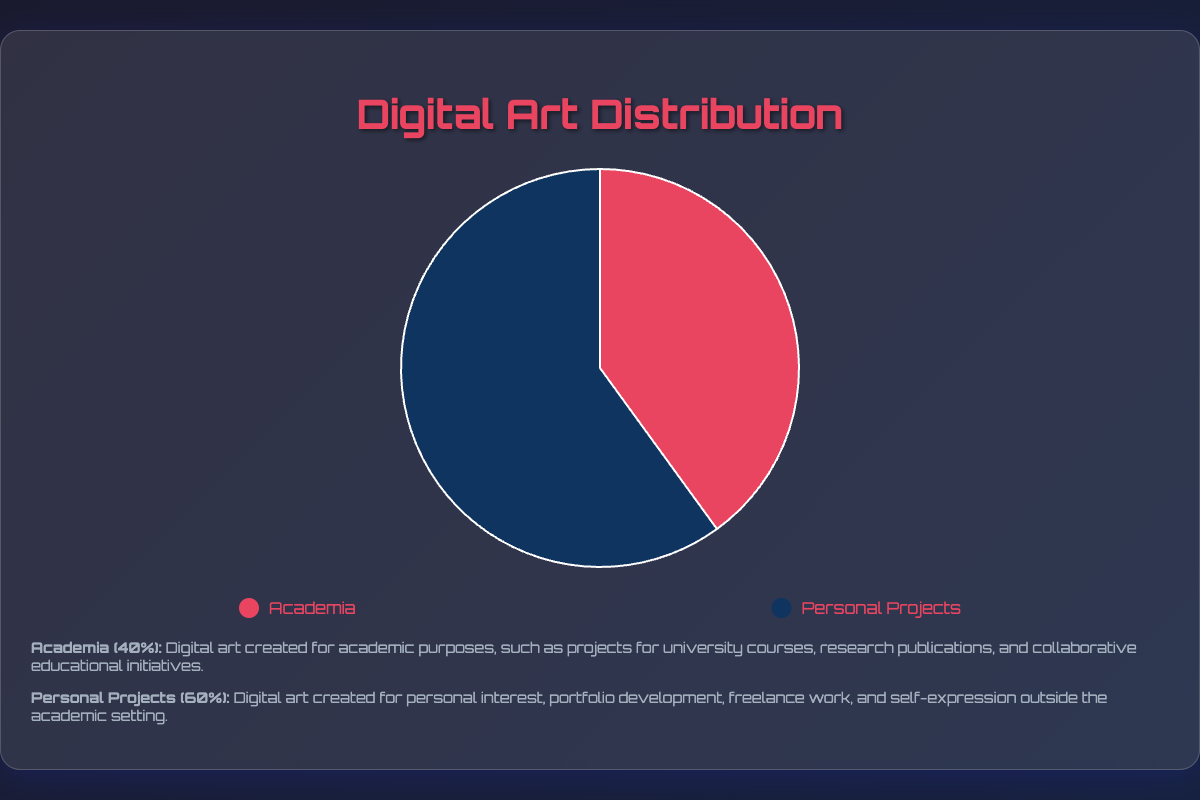What percentage of digital art is created for academia? Observing the pie chart, the segment labeled "Academia" occupies 40% of the total pie.
Answer: 40% What percentage of digital art is created for personal projects? The pie chart indicates that the segment labeled "Personal Projects" occupies 60% of the total pie.
Answer: 60% How does the proportion of personal projects compare to academia in digital art creation? The pie chart shows that personal projects constitute a larger portion (60%) compared to academia (40%), making personal projects the greater proportion.
Answer: Personal projects are greater What is the total percentage of digital art created combining both academia and personal projects? Combining the percentages, academia (40%) and personal projects (60%) gives us 40% + 60% = 100%.
Answer: 100% What is the difference in the percentage of digital art between personal projects and academia? Subtracting the percentage for academia (40%) from the percentage for personal projects (60%) results in a difference of 60% - 40% = 20%.
Answer: 20% Which segment of digital art creation is indicated by the color red? By examining the legend, the color red represents the "Academia" segment.
Answer: Academia Which segment of digital art creation is indicated by the color blue? According to the legend, the color blue represents the "Personal Projects" segment.
Answer: Personal Projects If the total number of digital artworks is 200, how many artworks were created for personal projects? Calculating 60% of 200 artworks: \( \frac{60}{100} \times 200 = 120 \) artworks.
Answer: 120 If there are 80 pieces of digital art created for academia, what is the total number of digital artworks? Given that 40% of the total artworks equal 80, \( \frac{80}{40} \times 100 = 200 \) total artworks.
Answer: 200 If the percentage of digital art for personal projects increased to 70%, what would be the updated percentage for academia? Since the total must equal 100%, if personal projects increased to 70%, academia would be 100% - 70% = 30%.
Answer: 30% 